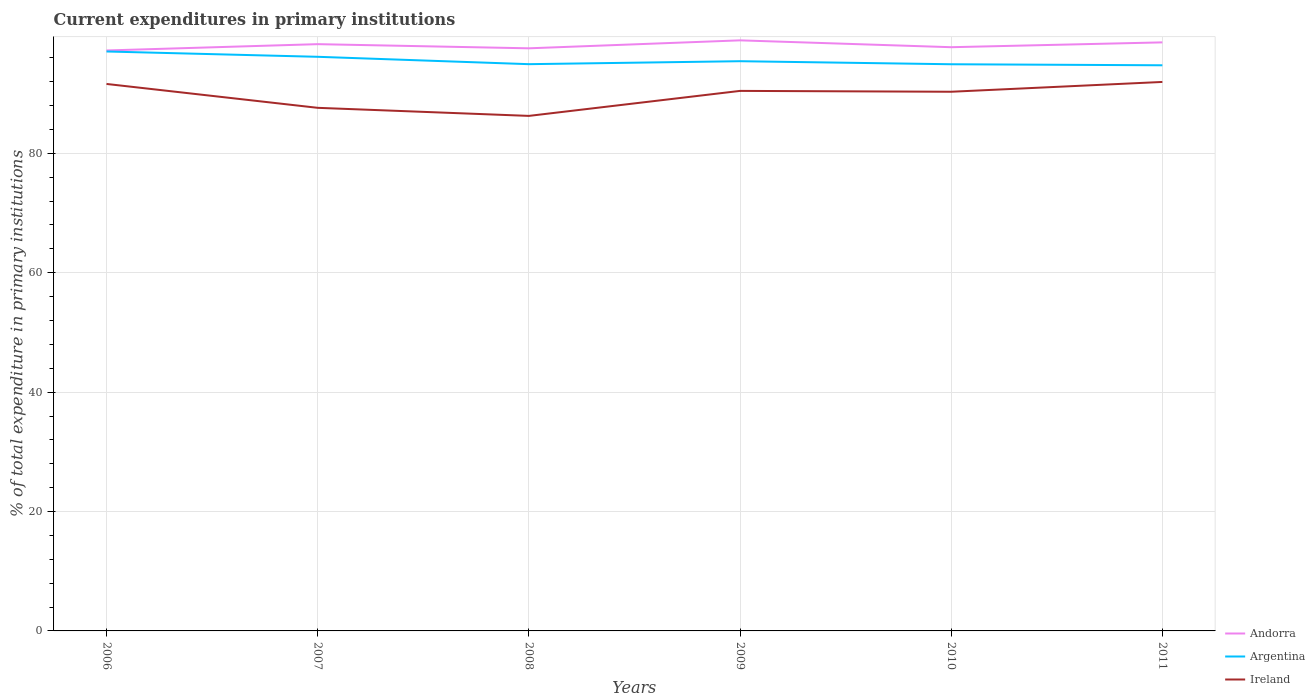How many different coloured lines are there?
Give a very brief answer. 3. Across all years, what is the maximum current expenditures in primary institutions in Ireland?
Keep it short and to the point. 86.27. What is the total current expenditures in primary institutions in Ireland in the graph?
Your answer should be very brief. 1.16. What is the difference between the highest and the second highest current expenditures in primary institutions in Argentina?
Offer a very short reply. 2.31. What is the difference between the highest and the lowest current expenditures in primary institutions in Argentina?
Your response must be concise. 2. Does the graph contain any zero values?
Your answer should be compact. No. Does the graph contain grids?
Offer a terse response. Yes. How many legend labels are there?
Give a very brief answer. 3. How are the legend labels stacked?
Offer a very short reply. Vertical. What is the title of the graph?
Ensure brevity in your answer.  Current expenditures in primary institutions. What is the label or title of the X-axis?
Make the answer very short. Years. What is the label or title of the Y-axis?
Offer a terse response. % of total expenditure in primary institutions. What is the % of total expenditure in primary institutions of Andorra in 2006?
Provide a succinct answer. 97.23. What is the % of total expenditure in primary institutions of Argentina in 2006?
Offer a terse response. 97.06. What is the % of total expenditure in primary institutions in Ireland in 2006?
Offer a terse response. 91.62. What is the % of total expenditure in primary institutions of Andorra in 2007?
Keep it short and to the point. 98.28. What is the % of total expenditure in primary institutions in Argentina in 2007?
Offer a very short reply. 96.17. What is the % of total expenditure in primary institutions in Ireland in 2007?
Give a very brief answer. 87.62. What is the % of total expenditure in primary institutions of Andorra in 2008?
Your answer should be very brief. 97.59. What is the % of total expenditure in primary institutions of Argentina in 2008?
Offer a very short reply. 94.93. What is the % of total expenditure in primary institutions of Ireland in 2008?
Ensure brevity in your answer.  86.27. What is the % of total expenditure in primary institutions in Andorra in 2009?
Give a very brief answer. 98.92. What is the % of total expenditure in primary institutions in Argentina in 2009?
Give a very brief answer. 95.43. What is the % of total expenditure in primary institutions in Ireland in 2009?
Provide a short and direct response. 90.46. What is the % of total expenditure in primary institutions in Andorra in 2010?
Your answer should be very brief. 97.77. What is the % of total expenditure in primary institutions of Argentina in 2010?
Provide a succinct answer. 94.92. What is the % of total expenditure in primary institutions of Ireland in 2010?
Your response must be concise. 90.31. What is the % of total expenditure in primary institutions in Andorra in 2011?
Make the answer very short. 98.58. What is the % of total expenditure in primary institutions of Argentina in 2011?
Provide a short and direct response. 94.75. What is the % of total expenditure in primary institutions of Ireland in 2011?
Provide a succinct answer. 91.96. Across all years, what is the maximum % of total expenditure in primary institutions in Andorra?
Provide a succinct answer. 98.92. Across all years, what is the maximum % of total expenditure in primary institutions of Argentina?
Your answer should be very brief. 97.06. Across all years, what is the maximum % of total expenditure in primary institutions of Ireland?
Your answer should be very brief. 91.96. Across all years, what is the minimum % of total expenditure in primary institutions in Andorra?
Offer a very short reply. 97.23. Across all years, what is the minimum % of total expenditure in primary institutions of Argentina?
Ensure brevity in your answer.  94.75. Across all years, what is the minimum % of total expenditure in primary institutions in Ireland?
Provide a short and direct response. 86.27. What is the total % of total expenditure in primary institutions in Andorra in the graph?
Ensure brevity in your answer.  588.38. What is the total % of total expenditure in primary institutions of Argentina in the graph?
Ensure brevity in your answer.  573.25. What is the total % of total expenditure in primary institutions of Ireland in the graph?
Make the answer very short. 538.23. What is the difference between the % of total expenditure in primary institutions of Andorra in 2006 and that in 2007?
Keep it short and to the point. -1.06. What is the difference between the % of total expenditure in primary institutions of Argentina in 2006 and that in 2007?
Make the answer very short. 0.89. What is the difference between the % of total expenditure in primary institutions of Ireland in 2006 and that in 2007?
Provide a short and direct response. 4. What is the difference between the % of total expenditure in primary institutions in Andorra in 2006 and that in 2008?
Offer a terse response. -0.36. What is the difference between the % of total expenditure in primary institutions in Argentina in 2006 and that in 2008?
Make the answer very short. 2.12. What is the difference between the % of total expenditure in primary institutions in Ireland in 2006 and that in 2008?
Provide a short and direct response. 5.35. What is the difference between the % of total expenditure in primary institutions in Andorra in 2006 and that in 2009?
Your answer should be compact. -1.7. What is the difference between the % of total expenditure in primary institutions in Argentina in 2006 and that in 2009?
Make the answer very short. 1.63. What is the difference between the % of total expenditure in primary institutions of Ireland in 2006 and that in 2009?
Make the answer very short. 1.16. What is the difference between the % of total expenditure in primary institutions of Andorra in 2006 and that in 2010?
Give a very brief answer. -0.55. What is the difference between the % of total expenditure in primary institutions in Argentina in 2006 and that in 2010?
Give a very brief answer. 2.14. What is the difference between the % of total expenditure in primary institutions of Ireland in 2006 and that in 2010?
Offer a terse response. 1.31. What is the difference between the % of total expenditure in primary institutions of Andorra in 2006 and that in 2011?
Offer a terse response. -1.36. What is the difference between the % of total expenditure in primary institutions in Argentina in 2006 and that in 2011?
Provide a short and direct response. 2.31. What is the difference between the % of total expenditure in primary institutions in Ireland in 2006 and that in 2011?
Your response must be concise. -0.34. What is the difference between the % of total expenditure in primary institutions of Andorra in 2007 and that in 2008?
Keep it short and to the point. 0.7. What is the difference between the % of total expenditure in primary institutions in Argentina in 2007 and that in 2008?
Give a very brief answer. 1.23. What is the difference between the % of total expenditure in primary institutions of Ireland in 2007 and that in 2008?
Your response must be concise. 1.35. What is the difference between the % of total expenditure in primary institutions of Andorra in 2007 and that in 2009?
Ensure brevity in your answer.  -0.64. What is the difference between the % of total expenditure in primary institutions in Argentina in 2007 and that in 2009?
Provide a succinct answer. 0.74. What is the difference between the % of total expenditure in primary institutions of Ireland in 2007 and that in 2009?
Keep it short and to the point. -2.84. What is the difference between the % of total expenditure in primary institutions in Andorra in 2007 and that in 2010?
Your response must be concise. 0.51. What is the difference between the % of total expenditure in primary institutions of Argentina in 2007 and that in 2010?
Your answer should be compact. 1.25. What is the difference between the % of total expenditure in primary institutions of Ireland in 2007 and that in 2010?
Offer a very short reply. -2.69. What is the difference between the % of total expenditure in primary institutions of Andorra in 2007 and that in 2011?
Your answer should be very brief. -0.3. What is the difference between the % of total expenditure in primary institutions of Argentina in 2007 and that in 2011?
Provide a short and direct response. 1.42. What is the difference between the % of total expenditure in primary institutions in Ireland in 2007 and that in 2011?
Your answer should be very brief. -4.33. What is the difference between the % of total expenditure in primary institutions in Andorra in 2008 and that in 2009?
Ensure brevity in your answer.  -1.33. What is the difference between the % of total expenditure in primary institutions in Argentina in 2008 and that in 2009?
Offer a terse response. -0.5. What is the difference between the % of total expenditure in primary institutions in Ireland in 2008 and that in 2009?
Give a very brief answer. -4.19. What is the difference between the % of total expenditure in primary institutions of Andorra in 2008 and that in 2010?
Offer a very short reply. -0.19. What is the difference between the % of total expenditure in primary institutions in Argentina in 2008 and that in 2010?
Your answer should be very brief. 0.01. What is the difference between the % of total expenditure in primary institutions in Ireland in 2008 and that in 2010?
Keep it short and to the point. -4.04. What is the difference between the % of total expenditure in primary institutions in Andorra in 2008 and that in 2011?
Your answer should be very brief. -0.99. What is the difference between the % of total expenditure in primary institutions of Argentina in 2008 and that in 2011?
Offer a terse response. 0.19. What is the difference between the % of total expenditure in primary institutions in Ireland in 2008 and that in 2011?
Provide a succinct answer. -5.69. What is the difference between the % of total expenditure in primary institutions in Andorra in 2009 and that in 2010?
Provide a succinct answer. 1.15. What is the difference between the % of total expenditure in primary institutions of Argentina in 2009 and that in 2010?
Ensure brevity in your answer.  0.51. What is the difference between the % of total expenditure in primary institutions in Ireland in 2009 and that in 2010?
Provide a succinct answer. 0.14. What is the difference between the % of total expenditure in primary institutions in Andorra in 2009 and that in 2011?
Keep it short and to the point. 0.34. What is the difference between the % of total expenditure in primary institutions of Argentina in 2009 and that in 2011?
Your response must be concise. 0.68. What is the difference between the % of total expenditure in primary institutions in Ireland in 2009 and that in 2011?
Provide a succinct answer. -1.5. What is the difference between the % of total expenditure in primary institutions of Andorra in 2010 and that in 2011?
Keep it short and to the point. -0.81. What is the difference between the % of total expenditure in primary institutions in Argentina in 2010 and that in 2011?
Make the answer very short. 0.17. What is the difference between the % of total expenditure in primary institutions of Ireland in 2010 and that in 2011?
Your response must be concise. -1.64. What is the difference between the % of total expenditure in primary institutions of Andorra in 2006 and the % of total expenditure in primary institutions of Argentina in 2007?
Your answer should be compact. 1.06. What is the difference between the % of total expenditure in primary institutions in Andorra in 2006 and the % of total expenditure in primary institutions in Ireland in 2007?
Give a very brief answer. 9.61. What is the difference between the % of total expenditure in primary institutions of Argentina in 2006 and the % of total expenditure in primary institutions of Ireland in 2007?
Provide a short and direct response. 9.44. What is the difference between the % of total expenditure in primary institutions in Andorra in 2006 and the % of total expenditure in primary institutions in Argentina in 2008?
Ensure brevity in your answer.  2.29. What is the difference between the % of total expenditure in primary institutions of Andorra in 2006 and the % of total expenditure in primary institutions of Ireland in 2008?
Ensure brevity in your answer.  10.96. What is the difference between the % of total expenditure in primary institutions of Argentina in 2006 and the % of total expenditure in primary institutions of Ireland in 2008?
Give a very brief answer. 10.79. What is the difference between the % of total expenditure in primary institutions of Andorra in 2006 and the % of total expenditure in primary institutions of Argentina in 2009?
Keep it short and to the point. 1.8. What is the difference between the % of total expenditure in primary institutions in Andorra in 2006 and the % of total expenditure in primary institutions in Ireland in 2009?
Your answer should be compact. 6.77. What is the difference between the % of total expenditure in primary institutions of Argentina in 2006 and the % of total expenditure in primary institutions of Ireland in 2009?
Your answer should be very brief. 6.6. What is the difference between the % of total expenditure in primary institutions in Andorra in 2006 and the % of total expenditure in primary institutions in Argentina in 2010?
Your response must be concise. 2.31. What is the difference between the % of total expenditure in primary institutions of Andorra in 2006 and the % of total expenditure in primary institutions of Ireland in 2010?
Ensure brevity in your answer.  6.91. What is the difference between the % of total expenditure in primary institutions of Argentina in 2006 and the % of total expenditure in primary institutions of Ireland in 2010?
Your answer should be very brief. 6.74. What is the difference between the % of total expenditure in primary institutions of Andorra in 2006 and the % of total expenditure in primary institutions of Argentina in 2011?
Your answer should be very brief. 2.48. What is the difference between the % of total expenditure in primary institutions of Andorra in 2006 and the % of total expenditure in primary institutions of Ireland in 2011?
Ensure brevity in your answer.  5.27. What is the difference between the % of total expenditure in primary institutions in Argentina in 2006 and the % of total expenditure in primary institutions in Ireland in 2011?
Offer a very short reply. 5.1. What is the difference between the % of total expenditure in primary institutions in Andorra in 2007 and the % of total expenditure in primary institutions in Argentina in 2008?
Make the answer very short. 3.35. What is the difference between the % of total expenditure in primary institutions in Andorra in 2007 and the % of total expenditure in primary institutions in Ireland in 2008?
Your answer should be compact. 12.02. What is the difference between the % of total expenditure in primary institutions of Argentina in 2007 and the % of total expenditure in primary institutions of Ireland in 2008?
Your response must be concise. 9.9. What is the difference between the % of total expenditure in primary institutions in Andorra in 2007 and the % of total expenditure in primary institutions in Argentina in 2009?
Your answer should be very brief. 2.86. What is the difference between the % of total expenditure in primary institutions of Andorra in 2007 and the % of total expenditure in primary institutions of Ireland in 2009?
Offer a very short reply. 7.83. What is the difference between the % of total expenditure in primary institutions of Argentina in 2007 and the % of total expenditure in primary institutions of Ireland in 2009?
Your answer should be compact. 5.71. What is the difference between the % of total expenditure in primary institutions in Andorra in 2007 and the % of total expenditure in primary institutions in Argentina in 2010?
Keep it short and to the point. 3.37. What is the difference between the % of total expenditure in primary institutions of Andorra in 2007 and the % of total expenditure in primary institutions of Ireland in 2010?
Provide a short and direct response. 7.97. What is the difference between the % of total expenditure in primary institutions of Argentina in 2007 and the % of total expenditure in primary institutions of Ireland in 2010?
Ensure brevity in your answer.  5.85. What is the difference between the % of total expenditure in primary institutions in Andorra in 2007 and the % of total expenditure in primary institutions in Argentina in 2011?
Your answer should be compact. 3.54. What is the difference between the % of total expenditure in primary institutions of Andorra in 2007 and the % of total expenditure in primary institutions of Ireland in 2011?
Offer a very short reply. 6.33. What is the difference between the % of total expenditure in primary institutions of Argentina in 2007 and the % of total expenditure in primary institutions of Ireland in 2011?
Provide a succinct answer. 4.21. What is the difference between the % of total expenditure in primary institutions in Andorra in 2008 and the % of total expenditure in primary institutions in Argentina in 2009?
Offer a very short reply. 2.16. What is the difference between the % of total expenditure in primary institutions of Andorra in 2008 and the % of total expenditure in primary institutions of Ireland in 2009?
Your answer should be very brief. 7.13. What is the difference between the % of total expenditure in primary institutions of Argentina in 2008 and the % of total expenditure in primary institutions of Ireland in 2009?
Make the answer very short. 4.48. What is the difference between the % of total expenditure in primary institutions of Andorra in 2008 and the % of total expenditure in primary institutions of Argentina in 2010?
Ensure brevity in your answer.  2.67. What is the difference between the % of total expenditure in primary institutions in Andorra in 2008 and the % of total expenditure in primary institutions in Ireland in 2010?
Your answer should be compact. 7.27. What is the difference between the % of total expenditure in primary institutions in Argentina in 2008 and the % of total expenditure in primary institutions in Ireland in 2010?
Provide a succinct answer. 4.62. What is the difference between the % of total expenditure in primary institutions in Andorra in 2008 and the % of total expenditure in primary institutions in Argentina in 2011?
Make the answer very short. 2.84. What is the difference between the % of total expenditure in primary institutions in Andorra in 2008 and the % of total expenditure in primary institutions in Ireland in 2011?
Provide a short and direct response. 5.63. What is the difference between the % of total expenditure in primary institutions in Argentina in 2008 and the % of total expenditure in primary institutions in Ireland in 2011?
Provide a short and direct response. 2.98. What is the difference between the % of total expenditure in primary institutions of Andorra in 2009 and the % of total expenditure in primary institutions of Argentina in 2010?
Ensure brevity in your answer.  4. What is the difference between the % of total expenditure in primary institutions in Andorra in 2009 and the % of total expenditure in primary institutions in Ireland in 2010?
Give a very brief answer. 8.61. What is the difference between the % of total expenditure in primary institutions of Argentina in 2009 and the % of total expenditure in primary institutions of Ireland in 2010?
Your answer should be compact. 5.12. What is the difference between the % of total expenditure in primary institutions in Andorra in 2009 and the % of total expenditure in primary institutions in Argentina in 2011?
Ensure brevity in your answer.  4.18. What is the difference between the % of total expenditure in primary institutions of Andorra in 2009 and the % of total expenditure in primary institutions of Ireland in 2011?
Your response must be concise. 6.97. What is the difference between the % of total expenditure in primary institutions in Argentina in 2009 and the % of total expenditure in primary institutions in Ireland in 2011?
Offer a very short reply. 3.47. What is the difference between the % of total expenditure in primary institutions in Andorra in 2010 and the % of total expenditure in primary institutions in Argentina in 2011?
Offer a very short reply. 3.03. What is the difference between the % of total expenditure in primary institutions of Andorra in 2010 and the % of total expenditure in primary institutions of Ireland in 2011?
Your answer should be very brief. 5.82. What is the difference between the % of total expenditure in primary institutions in Argentina in 2010 and the % of total expenditure in primary institutions in Ireland in 2011?
Ensure brevity in your answer.  2.96. What is the average % of total expenditure in primary institutions of Andorra per year?
Provide a succinct answer. 98.06. What is the average % of total expenditure in primary institutions of Argentina per year?
Make the answer very short. 95.54. What is the average % of total expenditure in primary institutions in Ireland per year?
Provide a short and direct response. 89.71. In the year 2006, what is the difference between the % of total expenditure in primary institutions in Andorra and % of total expenditure in primary institutions in Argentina?
Your answer should be very brief. 0.17. In the year 2006, what is the difference between the % of total expenditure in primary institutions in Andorra and % of total expenditure in primary institutions in Ireland?
Offer a terse response. 5.61. In the year 2006, what is the difference between the % of total expenditure in primary institutions of Argentina and % of total expenditure in primary institutions of Ireland?
Offer a terse response. 5.44. In the year 2007, what is the difference between the % of total expenditure in primary institutions in Andorra and % of total expenditure in primary institutions in Argentina?
Keep it short and to the point. 2.12. In the year 2007, what is the difference between the % of total expenditure in primary institutions in Andorra and % of total expenditure in primary institutions in Ireland?
Give a very brief answer. 10.66. In the year 2007, what is the difference between the % of total expenditure in primary institutions of Argentina and % of total expenditure in primary institutions of Ireland?
Provide a short and direct response. 8.55. In the year 2008, what is the difference between the % of total expenditure in primary institutions of Andorra and % of total expenditure in primary institutions of Argentina?
Ensure brevity in your answer.  2.65. In the year 2008, what is the difference between the % of total expenditure in primary institutions in Andorra and % of total expenditure in primary institutions in Ireland?
Offer a very short reply. 11.32. In the year 2008, what is the difference between the % of total expenditure in primary institutions of Argentina and % of total expenditure in primary institutions of Ireland?
Offer a very short reply. 8.66. In the year 2009, what is the difference between the % of total expenditure in primary institutions in Andorra and % of total expenditure in primary institutions in Argentina?
Offer a very short reply. 3.49. In the year 2009, what is the difference between the % of total expenditure in primary institutions of Andorra and % of total expenditure in primary institutions of Ireland?
Your answer should be compact. 8.47. In the year 2009, what is the difference between the % of total expenditure in primary institutions in Argentina and % of total expenditure in primary institutions in Ireland?
Make the answer very short. 4.97. In the year 2010, what is the difference between the % of total expenditure in primary institutions of Andorra and % of total expenditure in primary institutions of Argentina?
Provide a succinct answer. 2.86. In the year 2010, what is the difference between the % of total expenditure in primary institutions of Andorra and % of total expenditure in primary institutions of Ireland?
Your response must be concise. 7.46. In the year 2010, what is the difference between the % of total expenditure in primary institutions of Argentina and % of total expenditure in primary institutions of Ireland?
Ensure brevity in your answer.  4.61. In the year 2011, what is the difference between the % of total expenditure in primary institutions of Andorra and % of total expenditure in primary institutions of Argentina?
Offer a terse response. 3.84. In the year 2011, what is the difference between the % of total expenditure in primary institutions in Andorra and % of total expenditure in primary institutions in Ireland?
Provide a succinct answer. 6.63. In the year 2011, what is the difference between the % of total expenditure in primary institutions of Argentina and % of total expenditure in primary institutions of Ireland?
Provide a short and direct response. 2.79. What is the ratio of the % of total expenditure in primary institutions in Andorra in 2006 to that in 2007?
Your answer should be compact. 0.99. What is the ratio of the % of total expenditure in primary institutions in Argentina in 2006 to that in 2007?
Provide a short and direct response. 1.01. What is the ratio of the % of total expenditure in primary institutions in Ireland in 2006 to that in 2007?
Make the answer very short. 1.05. What is the ratio of the % of total expenditure in primary institutions in Andorra in 2006 to that in 2008?
Ensure brevity in your answer.  1. What is the ratio of the % of total expenditure in primary institutions in Argentina in 2006 to that in 2008?
Offer a very short reply. 1.02. What is the ratio of the % of total expenditure in primary institutions in Ireland in 2006 to that in 2008?
Offer a terse response. 1.06. What is the ratio of the % of total expenditure in primary institutions of Andorra in 2006 to that in 2009?
Offer a very short reply. 0.98. What is the ratio of the % of total expenditure in primary institutions in Argentina in 2006 to that in 2009?
Provide a succinct answer. 1.02. What is the ratio of the % of total expenditure in primary institutions of Ireland in 2006 to that in 2009?
Provide a short and direct response. 1.01. What is the ratio of the % of total expenditure in primary institutions of Argentina in 2006 to that in 2010?
Provide a succinct answer. 1.02. What is the ratio of the % of total expenditure in primary institutions in Ireland in 2006 to that in 2010?
Provide a short and direct response. 1.01. What is the ratio of the % of total expenditure in primary institutions of Andorra in 2006 to that in 2011?
Give a very brief answer. 0.99. What is the ratio of the % of total expenditure in primary institutions of Argentina in 2006 to that in 2011?
Provide a succinct answer. 1.02. What is the ratio of the % of total expenditure in primary institutions of Andorra in 2007 to that in 2008?
Your response must be concise. 1.01. What is the ratio of the % of total expenditure in primary institutions in Argentina in 2007 to that in 2008?
Your answer should be compact. 1.01. What is the ratio of the % of total expenditure in primary institutions in Ireland in 2007 to that in 2008?
Provide a succinct answer. 1.02. What is the ratio of the % of total expenditure in primary institutions in Andorra in 2007 to that in 2009?
Give a very brief answer. 0.99. What is the ratio of the % of total expenditure in primary institutions of Argentina in 2007 to that in 2009?
Ensure brevity in your answer.  1.01. What is the ratio of the % of total expenditure in primary institutions in Ireland in 2007 to that in 2009?
Make the answer very short. 0.97. What is the ratio of the % of total expenditure in primary institutions in Argentina in 2007 to that in 2010?
Your answer should be compact. 1.01. What is the ratio of the % of total expenditure in primary institutions of Ireland in 2007 to that in 2010?
Make the answer very short. 0.97. What is the ratio of the % of total expenditure in primary institutions of Argentina in 2007 to that in 2011?
Your answer should be compact. 1.01. What is the ratio of the % of total expenditure in primary institutions of Ireland in 2007 to that in 2011?
Provide a short and direct response. 0.95. What is the ratio of the % of total expenditure in primary institutions in Andorra in 2008 to that in 2009?
Your answer should be very brief. 0.99. What is the ratio of the % of total expenditure in primary institutions in Ireland in 2008 to that in 2009?
Give a very brief answer. 0.95. What is the ratio of the % of total expenditure in primary institutions of Ireland in 2008 to that in 2010?
Give a very brief answer. 0.96. What is the ratio of the % of total expenditure in primary institutions in Andorra in 2008 to that in 2011?
Offer a terse response. 0.99. What is the ratio of the % of total expenditure in primary institutions of Ireland in 2008 to that in 2011?
Offer a terse response. 0.94. What is the ratio of the % of total expenditure in primary institutions in Andorra in 2009 to that in 2010?
Provide a short and direct response. 1.01. What is the ratio of the % of total expenditure in primary institutions of Argentina in 2009 to that in 2010?
Make the answer very short. 1.01. What is the ratio of the % of total expenditure in primary institutions in Andorra in 2009 to that in 2011?
Offer a terse response. 1. What is the ratio of the % of total expenditure in primary institutions of Ireland in 2009 to that in 2011?
Your answer should be very brief. 0.98. What is the ratio of the % of total expenditure in primary institutions of Andorra in 2010 to that in 2011?
Provide a short and direct response. 0.99. What is the ratio of the % of total expenditure in primary institutions of Argentina in 2010 to that in 2011?
Make the answer very short. 1. What is the ratio of the % of total expenditure in primary institutions in Ireland in 2010 to that in 2011?
Your answer should be compact. 0.98. What is the difference between the highest and the second highest % of total expenditure in primary institutions of Andorra?
Provide a succinct answer. 0.34. What is the difference between the highest and the second highest % of total expenditure in primary institutions of Argentina?
Offer a very short reply. 0.89. What is the difference between the highest and the second highest % of total expenditure in primary institutions of Ireland?
Your answer should be compact. 0.34. What is the difference between the highest and the lowest % of total expenditure in primary institutions of Andorra?
Give a very brief answer. 1.7. What is the difference between the highest and the lowest % of total expenditure in primary institutions of Argentina?
Your response must be concise. 2.31. What is the difference between the highest and the lowest % of total expenditure in primary institutions in Ireland?
Ensure brevity in your answer.  5.69. 